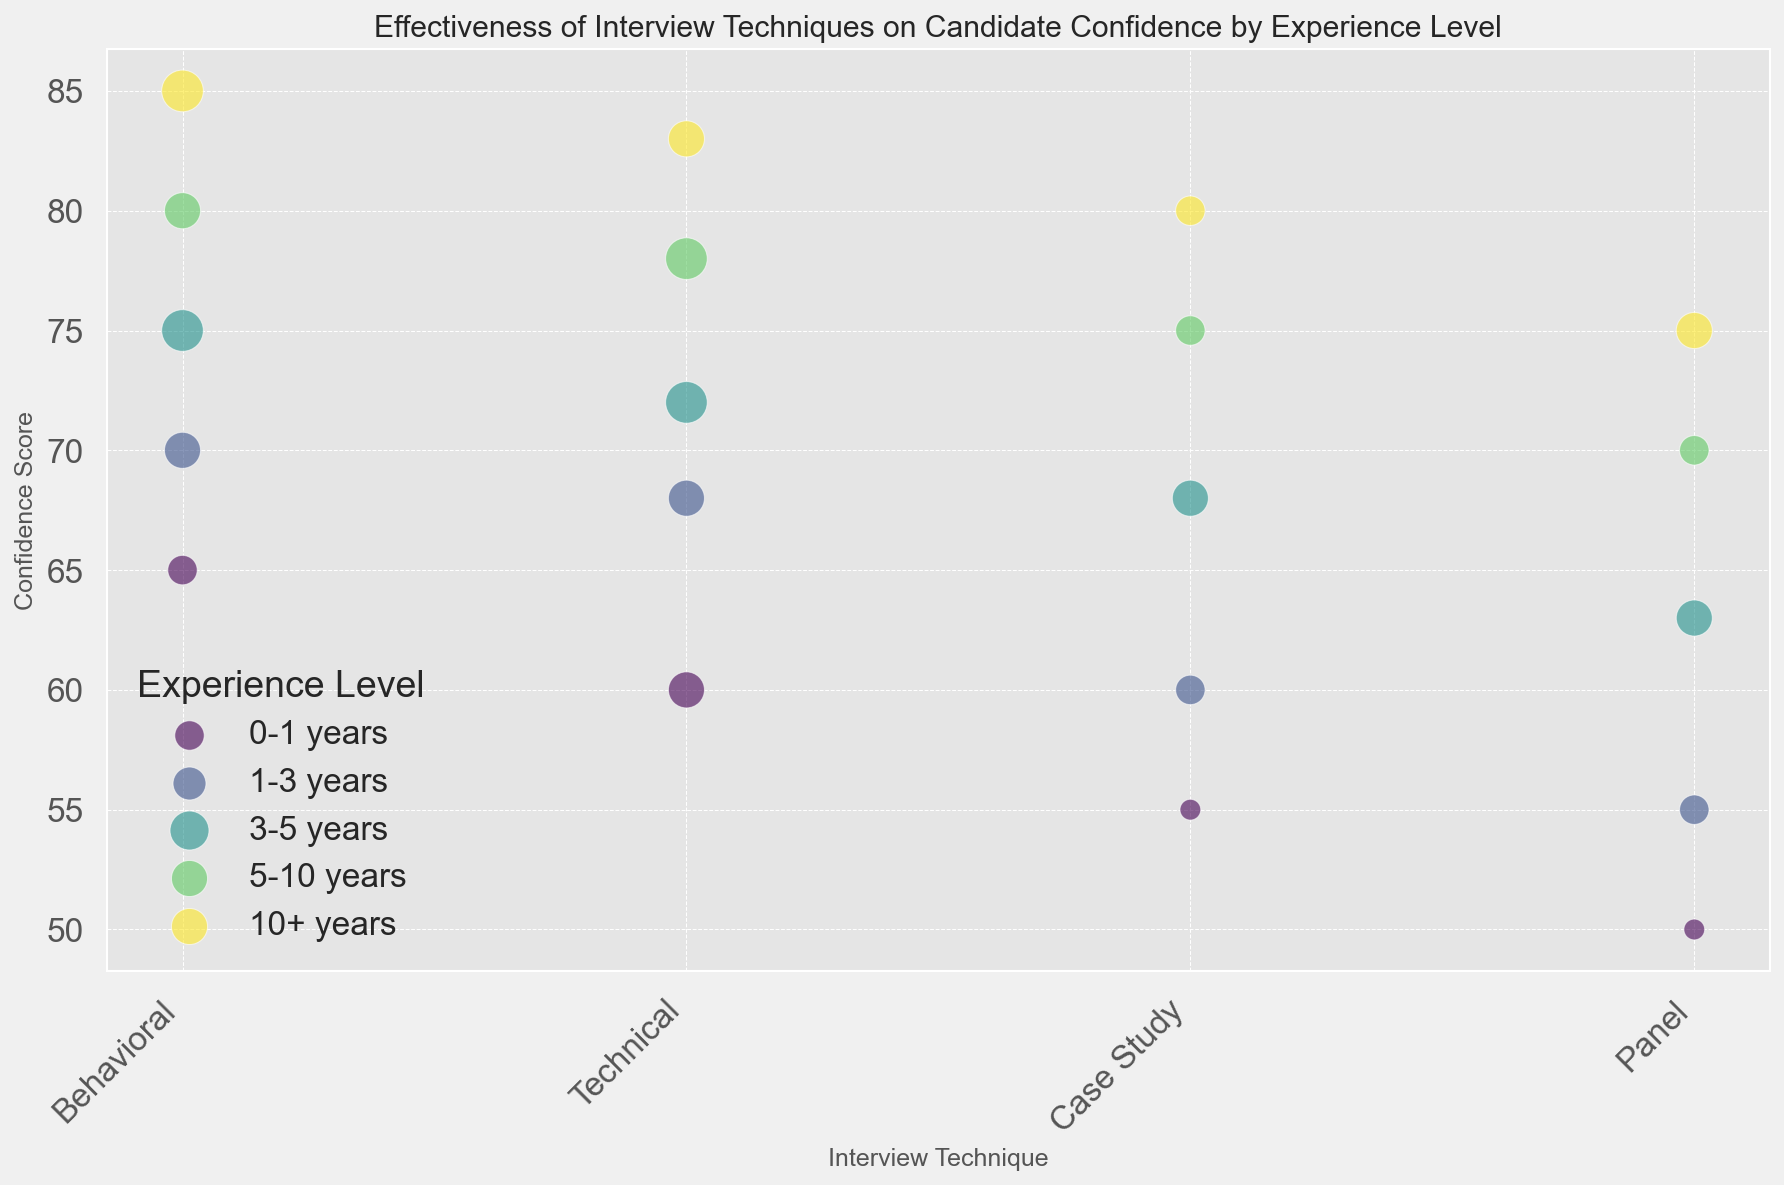What's the overall trend in confidence scores across different interview techniques for candidates with 5-10 years of experience? By examining the bubble chart for candidates with 5-10 years of experience, we observe that for "Behavioral," "Technical," "Case Study," and "Panel" techniques, the confidence scores are 80, 78, 75, and 70, respectively. The trend shows a general decrease in confidence scores as we move from "Behavioral" to "Panel."
Answer: Decreasing For candidates with 10+ years of experience, which interview technique has the highest confidence score? Looking at the bubbles representing the 10+ years experience group, "Behavioral" has the highest confidence score at 85.
Answer: Behavioral Between "Behavioral" and "Technical" interview techniques, which one had a higher impact factor for candidates with 3-5 years of experience? For candidates with 3-5 years of experience, the "Behavioral" technique has an impact factor of 4, while the "Technical" technique also has an impact factor of 4. Both techniques have the same impact factor.
Answer: Both are equal What is the difference in confidence score between the "Panel" interview technique for 0-1 years and 10+ years of experience groups? The "Panel" interview technique has a confidence score of 50 for 0-1 years of experience and 75 for 10+ years of experience. The difference in scores is 75 - 50 = 25.
Answer: 25 Which experience group has the most even distribution of confidence scores across all interview techniques? By observing the plot, the group with 1-3 years of experience shows a relatively even distribution of confidence scores: Behavioral (70), Technical (68), Case Study (60), and Panel (55). The differences in scores between techniques are relatively small compared to other groups.
Answer: 1-3 years For candidates with 5-10 years of experience, how does the confidence score for the "Case Study" technique compare to the "Panel" technique? For candidates with 5-10 years of experience, the confidence score for the "Case Study" technique is 75, whereas for the "Panel" technique, it is 70. Thus, the "Case Study" technique has a higher confidence score by 5 points compared to the "Panel" technique.
Answer: Higher by 5 points Which interview technique shows the highest impact factor for candidates with 0-1 years of experience? Observing the chart, the "Technical" interview technique has the highest impact factor of 3 for candidates with 0-1 years of experience.
Answer: Technical What is the average confidence score of the "Behavioral" interview technique across all experience levels? Summing the confidence scores for "Behavioral" interview technique across all experience levels: 65, 70, 75, 80, and 85. The total is 65 + 70 + 75 + 80 + 85 = 375. There are 5 scores. So, the average is 375 / 5 = 75.
Answer: 75 How does the confidence score of the "Case Study" technique for candidates with 3-5 years of experience compare to those with 0-1 years of experience? For 3-5 years experience, the confidence score for "Case Study" is 68, and for 0-1 years experience, it is 55. The difference is 68 - 55 = 13, indicating the score for 3-5 years is higher by 13 points.
Answer: Higher by 13 points 